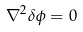<formula> <loc_0><loc_0><loc_500><loc_500>\nabla ^ { 2 } \delta \phi = 0</formula> 